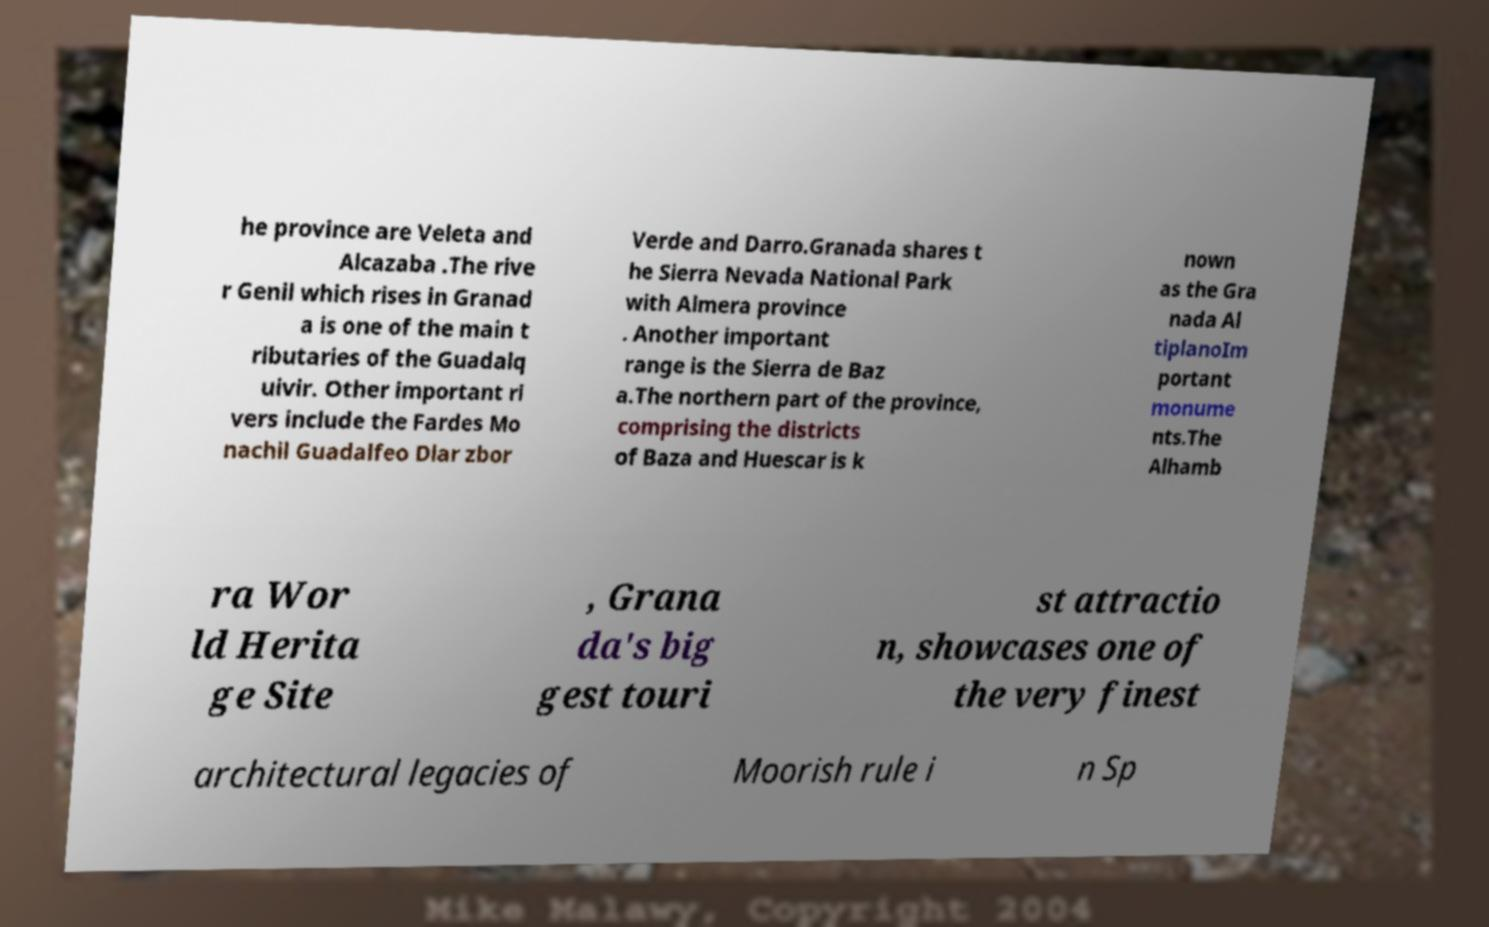There's text embedded in this image that I need extracted. Can you transcribe it verbatim? he province are Veleta and Alcazaba .The rive r Genil which rises in Granad a is one of the main t ributaries of the Guadalq uivir. Other important ri vers include the Fardes Mo nachil Guadalfeo Dlar zbor Verde and Darro.Granada shares t he Sierra Nevada National Park with Almera province . Another important range is the Sierra de Baz a.The northern part of the province, comprising the districts of Baza and Huescar is k nown as the Gra nada Al tiplanoIm portant monume nts.The Alhamb ra Wor ld Herita ge Site , Grana da's big gest touri st attractio n, showcases one of the very finest architectural legacies of Moorish rule i n Sp 